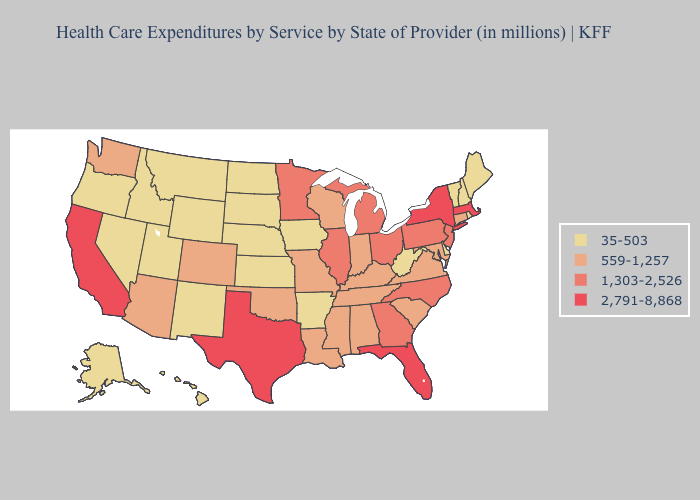Among the states that border Alabama , does Mississippi have the highest value?
Concise answer only. No. What is the value of Nebraska?
Give a very brief answer. 35-503. Does Minnesota have a lower value than South Dakota?
Keep it brief. No. What is the lowest value in the USA?
Give a very brief answer. 35-503. What is the highest value in states that border Wisconsin?
Quick response, please. 1,303-2,526. Name the states that have a value in the range 1,303-2,526?
Keep it brief. Georgia, Illinois, Michigan, Minnesota, New Jersey, North Carolina, Ohio, Pennsylvania. Name the states that have a value in the range 35-503?
Be succinct. Alaska, Arkansas, Delaware, Hawaii, Idaho, Iowa, Kansas, Maine, Montana, Nebraska, Nevada, New Hampshire, New Mexico, North Dakota, Oregon, Rhode Island, South Dakota, Utah, Vermont, West Virginia, Wyoming. What is the value of Washington?
Short answer required. 559-1,257. What is the highest value in states that border Washington?
Short answer required. 35-503. Which states have the highest value in the USA?
Quick response, please. California, Florida, Massachusetts, New York, Texas. What is the value of Delaware?
Give a very brief answer. 35-503. Does Arkansas have the lowest value in the South?
Concise answer only. Yes. What is the lowest value in the USA?
Answer briefly. 35-503. What is the lowest value in the Northeast?
Write a very short answer. 35-503. Does the first symbol in the legend represent the smallest category?
Keep it brief. Yes. 